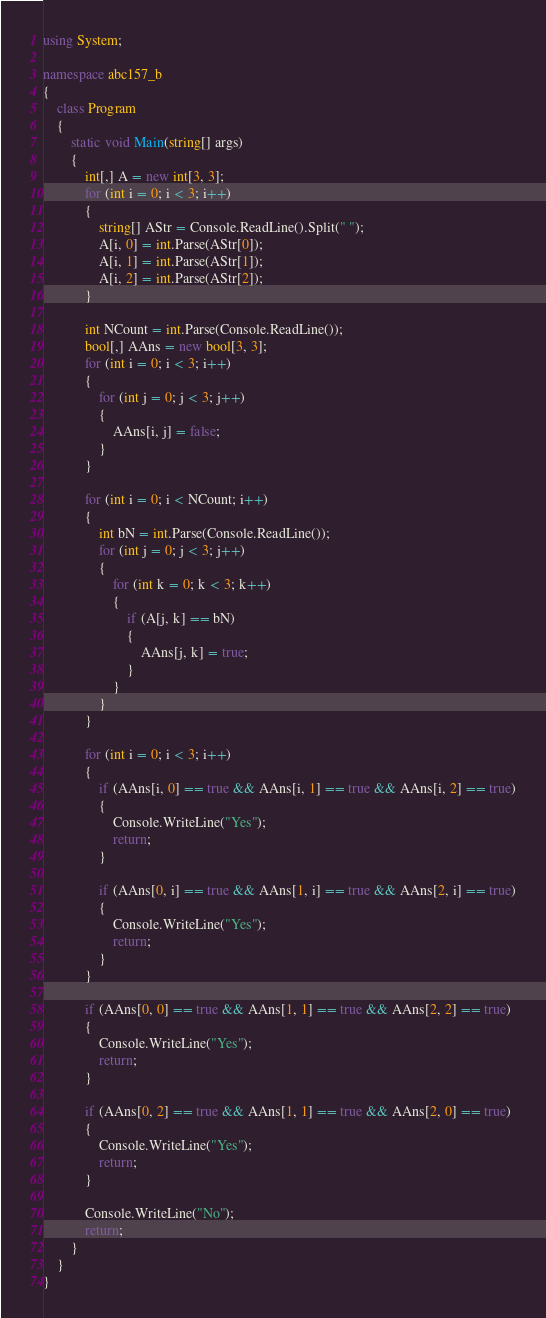Convert code to text. <code><loc_0><loc_0><loc_500><loc_500><_C#_>using System;

namespace abc157_b
{
    class Program
    {
        static void Main(string[] args)
        {
            int[,] A = new int[3, 3];
            for (int i = 0; i < 3; i++)
            {
                string[] AStr = Console.ReadLine().Split(" ");
                A[i, 0] = int.Parse(AStr[0]);
                A[i, 1] = int.Parse(AStr[1]);
                A[i, 2] = int.Parse(AStr[2]);
            }

            int NCount = int.Parse(Console.ReadLine());
            bool[,] AAns = new bool[3, 3];
            for (int i = 0; i < 3; i++)
            {
                for (int j = 0; j < 3; j++)
                {
                    AAns[i, j] = false;
                }
            }

            for (int i = 0; i < NCount; i++)
            {
                int bN = int.Parse(Console.ReadLine());
                for (int j = 0; j < 3; j++)
                {
                    for (int k = 0; k < 3; k++)
                    {
                        if (A[j, k] == bN)
                        {
                            AAns[j, k] = true;
                        }
                    }
                }
            }

            for (int i = 0; i < 3; i++)
            {
                if (AAns[i, 0] == true && AAns[i, 1] == true && AAns[i, 2] == true)
                {
                    Console.WriteLine("Yes");
                    return;
                }

                if (AAns[0, i] == true && AAns[1, i] == true && AAns[2, i] == true)
                {
                    Console.WriteLine("Yes");
                    return;
                }
            }

            if (AAns[0, 0] == true && AAns[1, 1] == true && AAns[2, 2] == true)
            {
                Console.WriteLine("Yes");
                return;
            }

            if (AAns[0, 2] == true && AAns[1, 1] == true && AAns[2, 0] == true)
            {
                Console.WriteLine("Yes");
                return;
            }

            Console.WriteLine("No");
            return;
        }
    }
}
</code> 